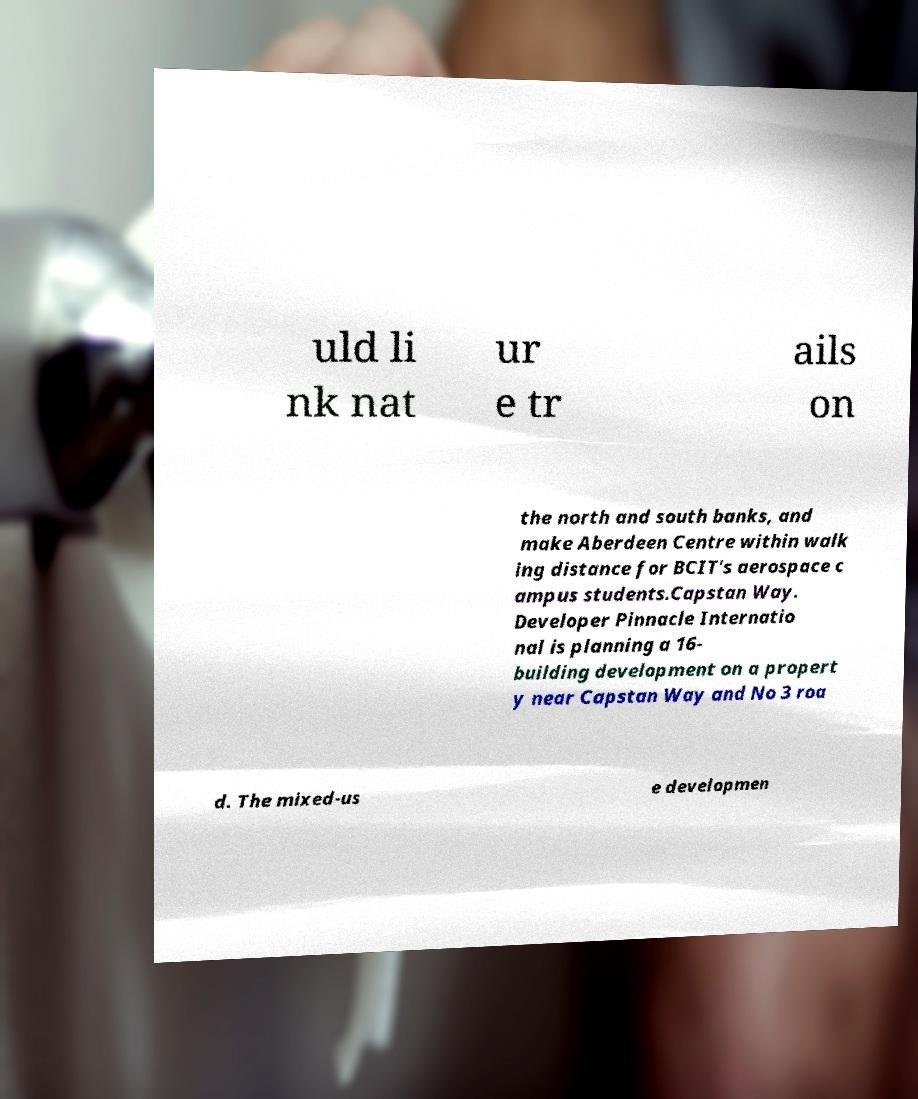For documentation purposes, I need the text within this image transcribed. Could you provide that? uld li nk nat ur e tr ails on the north and south banks, and make Aberdeen Centre within walk ing distance for BCIT's aerospace c ampus students.Capstan Way. Developer Pinnacle Internatio nal is planning a 16- building development on a propert y near Capstan Way and No 3 roa d. The mixed-us e developmen 